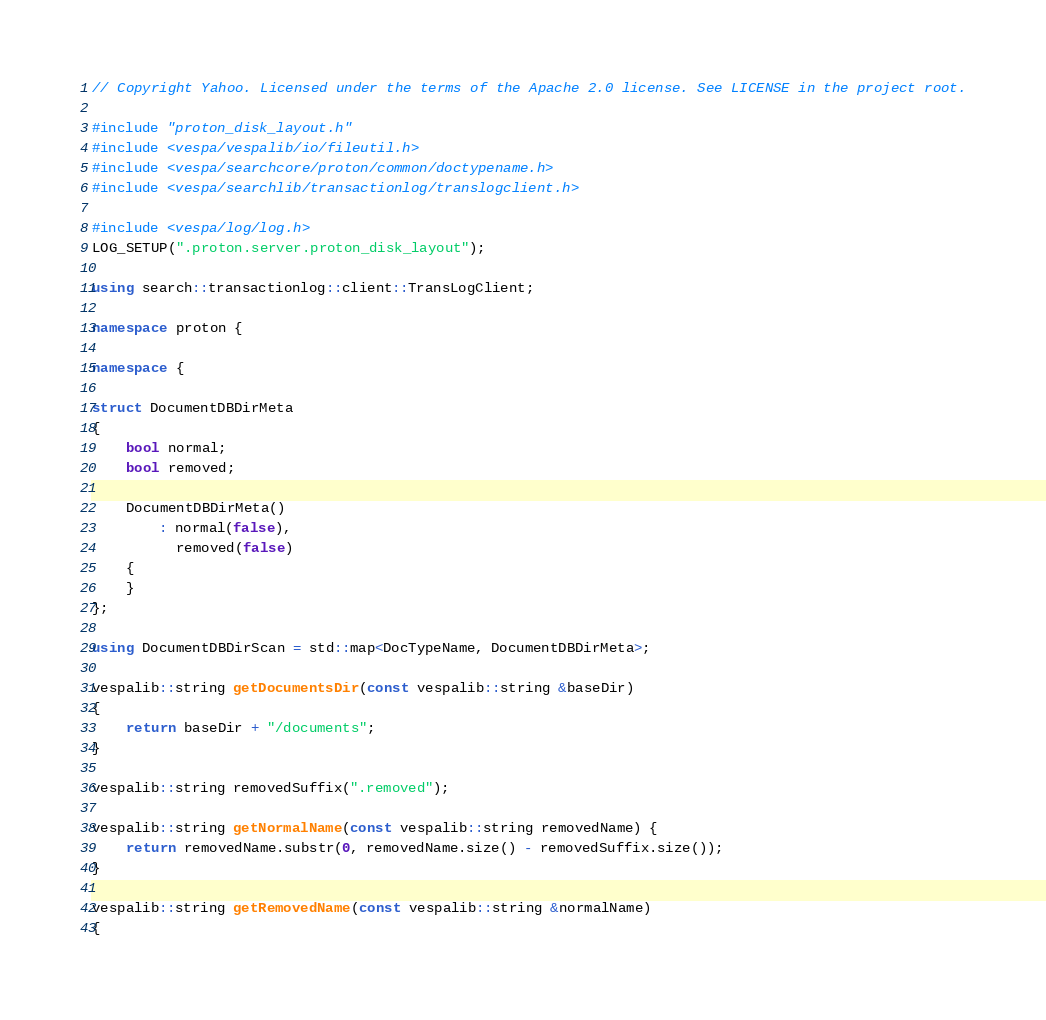<code> <loc_0><loc_0><loc_500><loc_500><_C++_>// Copyright Yahoo. Licensed under the terms of the Apache 2.0 license. See LICENSE in the project root.

#include "proton_disk_layout.h"
#include <vespa/vespalib/io/fileutil.h>
#include <vespa/searchcore/proton/common/doctypename.h>
#include <vespa/searchlib/transactionlog/translogclient.h>

#include <vespa/log/log.h>
LOG_SETUP(".proton.server.proton_disk_layout");

using search::transactionlog::client::TransLogClient;

namespace proton {

namespace {

struct DocumentDBDirMeta
{
    bool normal;
    bool removed;

    DocumentDBDirMeta()
        : normal(false),
          removed(false)
    {
    }
};

using DocumentDBDirScan = std::map<DocTypeName, DocumentDBDirMeta>;

vespalib::string getDocumentsDir(const vespalib::string &baseDir)
{
    return baseDir + "/documents";
}

vespalib::string removedSuffix(".removed");

vespalib::string getNormalName(const vespalib::string removedName) {
    return removedName.substr(0, removedName.size() - removedSuffix.size());
}

vespalib::string getRemovedName(const vespalib::string &normalName)
{</code> 